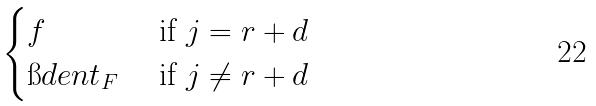Convert formula to latex. <formula><loc_0><loc_0><loc_500><loc_500>\begin{cases} f & \text { if } j = r + d \\ \i d e n t _ { F } & \text { if } j \ne r + d \end{cases}</formula> 